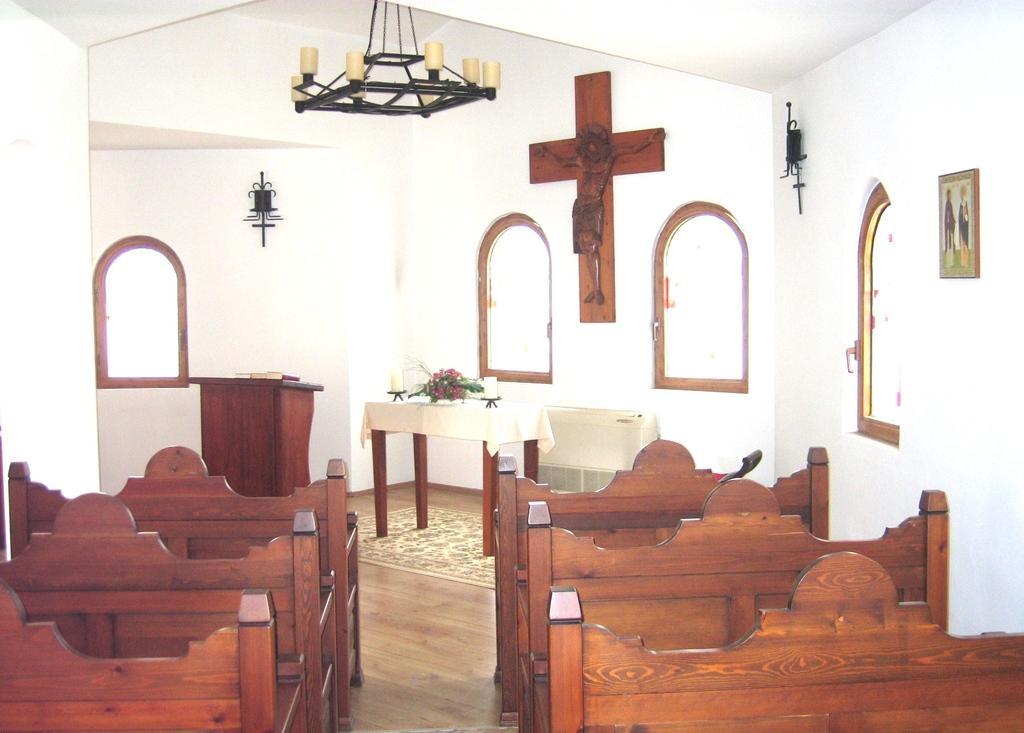How would you summarize this image in a sentence or two? Here we can see benches and we can see some objects on table. We can see wall,statue,frame and windows. 